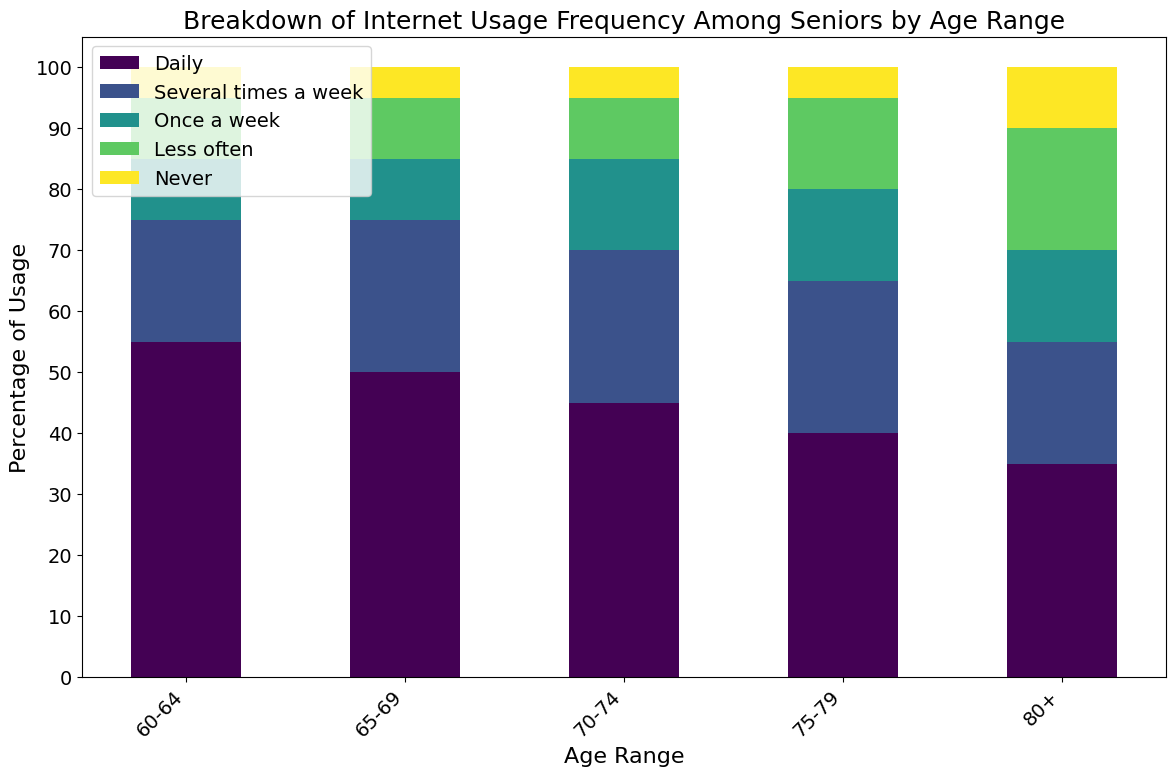What is the most frequent category of internet usage for seniors aged 60-64? Look at the tallest bar in the category for the age group 60-64. The tallest bar represents the "Daily" usage category.
Answer: Daily Which age range has the highest percentage of seniors who use the internet daily? Check the height of the "Daily" bars across all age ranges. The bar for the age range 60-64 is the tallest for the daily usage category.
Answer: 60-64 How does the 'Never' usage percentage for seniors aged 80+ compare to those aged 60-64? Look at the height of the 'Never' usage bars for both age ranges. The 'Never' bar for the 80+ age range is higher than that for the 60-64 age range.
Answer: Higher What is the total percentage of seniors in the 70-74 age range who use the internet less than once a week (adding 'Less often' and 'Never')? Sum the 'Less often' and 'Never' bars for the 70-74 age range. 10% (Less often) + 5% (Never) = 15%.
Answer: 15% In which age range is the difference between 'Daily' and 'Several times a week' usage the highest? Calculate the difference between the 'Daily' and 'Several times a week' bars for each age range. 60-64: 55-20 = 35, 65-69: 50-25 = 25, 70-74: 45-25 = 20, 75-79: 40-25 = 15, 80+: 35-20 = 15. The age range 60-64 has the highest difference of 35.
Answer: 60-64 What is the combined percentage of seniors aged 65-69 who use the internet either daily or several times a week? Sum the 'Daily' and 'Several times a week' bars for the age range 65-69. 50% (Daily) + 25% (Several times a week) = 75%.
Answer: 75% Which usage category shows the most significant decline as age increases from 60-64 to 80+? Compare the height of the bars within each usage category from the age range 60-64 to 80+. The 'Daily' category shows the most significant decline (from 55% to 35%).
Answer: Daily What percentage of seniors aged 75-79 use the internet at least once a week? Sum the 'Daily', 'Several times a week', and 'Once a week' bars for the age range 75-79. 40% (Daily) + 25% (Several times a week) + 15% (Once a week) = 80%.
Answer: 80% How does 'Once a week' usage change from the age range 70-74 to 80+? Compare the height of the 'Once a week' bars for the age ranges 70-74 and 80+. Both age ranges have the same 'Once a week' percentage (15%).
Answer: Stays the same 